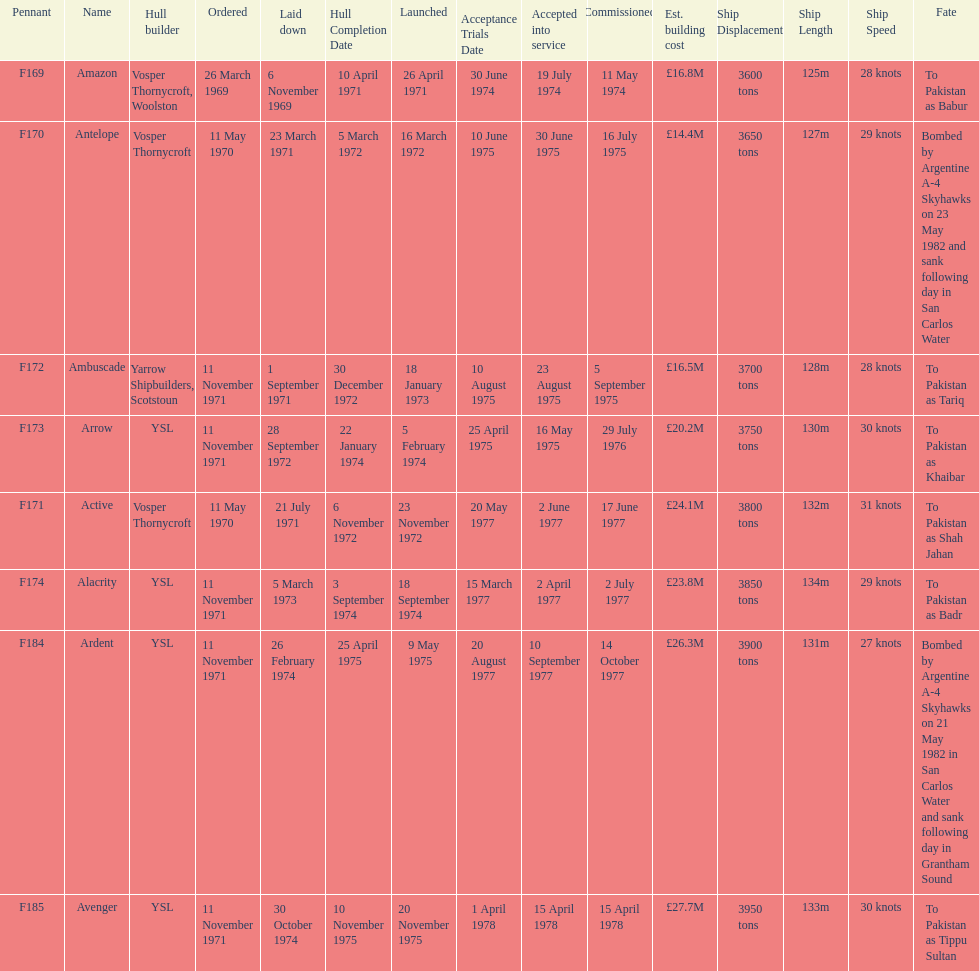What is the last name listed on this chart? Avenger. 